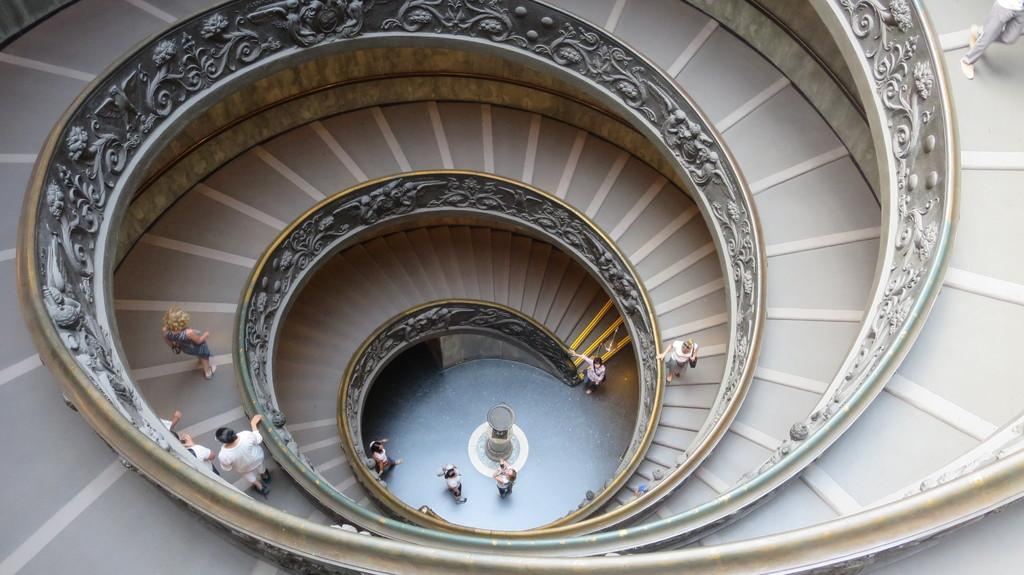What type of location is depicted in the image? The image shows the interior of a building. What architectural feature can be seen in the image? There are staircases in the image. How many people are present in the image? There are many people in the image. What is located on the floor in the image? There is an object on the floor in the image. What type of rhythm can be heard from the people in the image? There is no audible sound in the image, so it is not possible to determine any rhythm. 